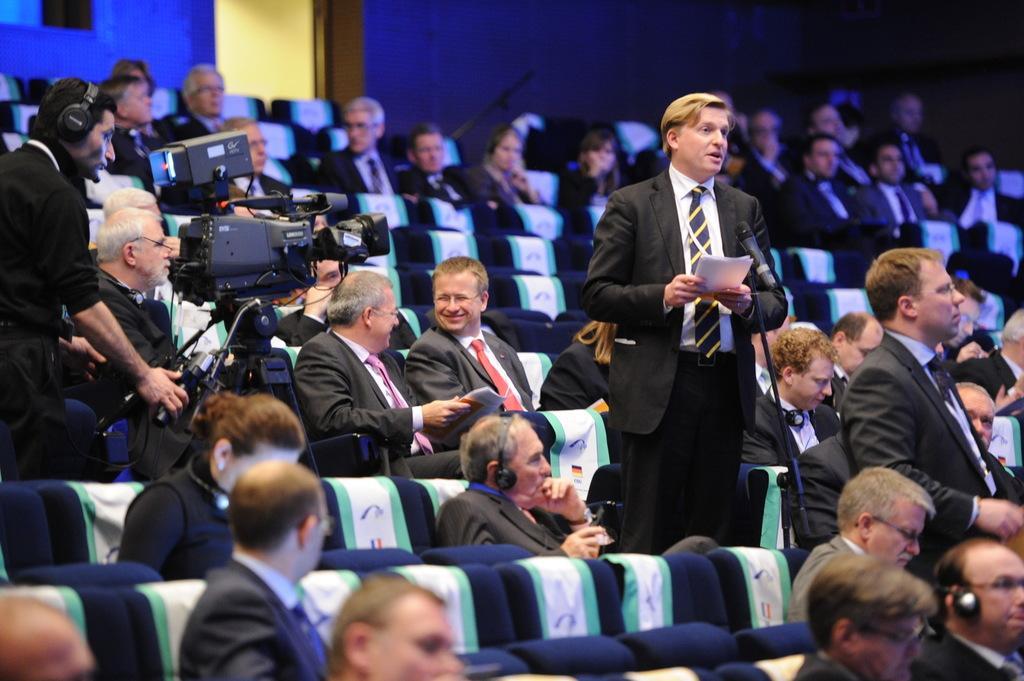In one or two sentences, can you explain what this image depicts? In the image we can see there are people sitting and two of them are standing, they are wearing clothes and some of them are wearing spectacles and headsets. Here we can see a man standing, holding paper and in front him there is a microphone. There is another man standing, wearing headsets and in front of him there is a video camera. Here we can see the wall and the door. 